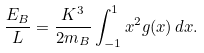<formula> <loc_0><loc_0><loc_500><loc_500>\frac { E _ { B } } { L } = \frac { K ^ { 3 } } { 2 m _ { B } } \int _ { - 1 } ^ { 1 } x ^ { 2 } g ( x ) \, d x .</formula> 